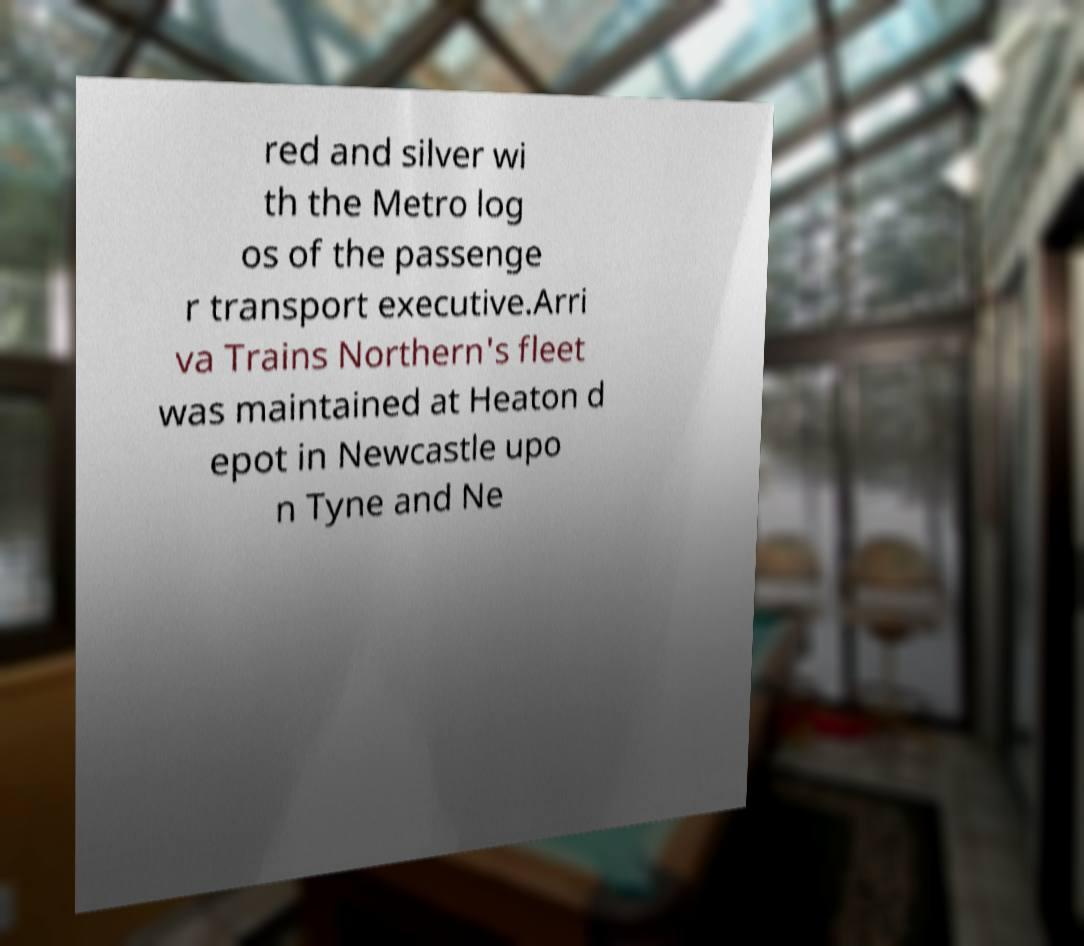Can you accurately transcribe the text from the provided image for me? red and silver wi th the Metro log os of the passenge r transport executive.Arri va Trains Northern's fleet was maintained at Heaton d epot in Newcastle upo n Tyne and Ne 